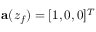<formula> <loc_0><loc_0><loc_500><loc_500>a ( z _ { f } ) = [ 1 , 0 , 0 ] ^ { T }</formula> 